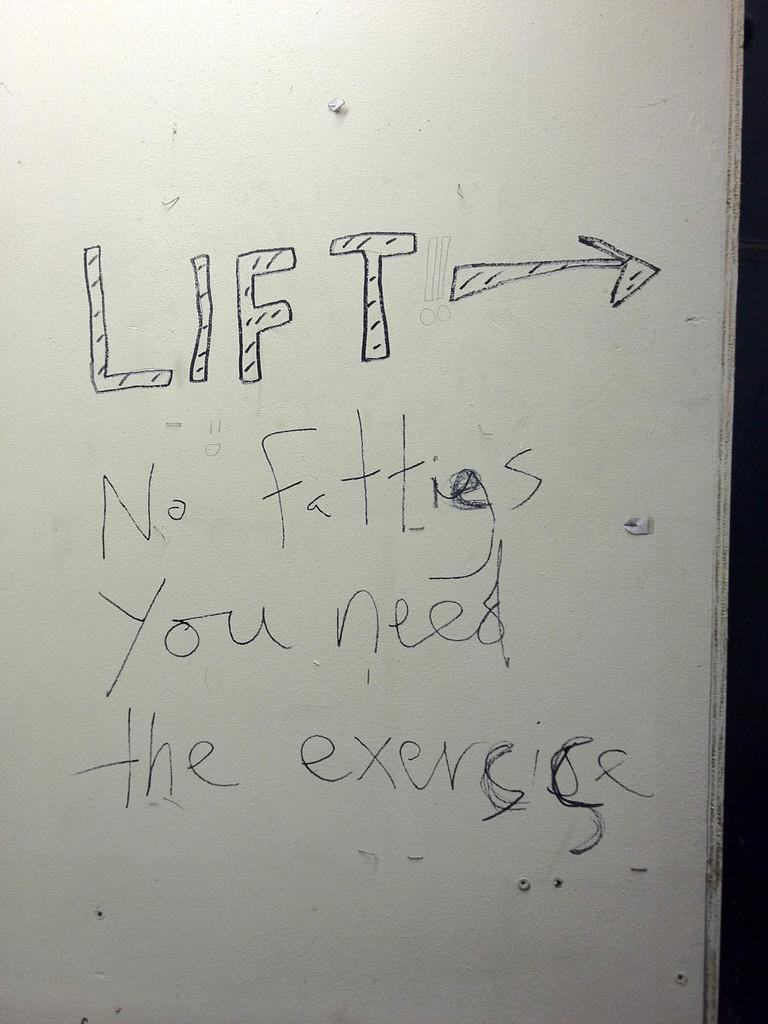<image>
Share a concise interpretation of the image provided. An insult is scrawled on a white door. 